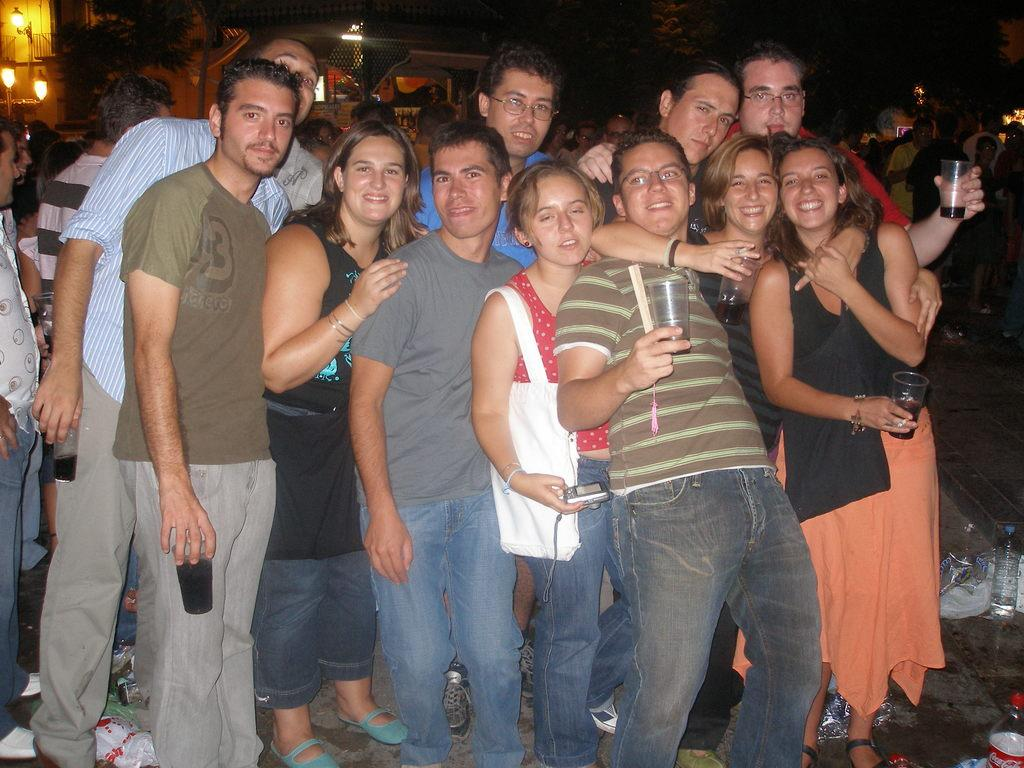What can be seen in the foreground of the image? There is a group of boys and girls in the image. What are the individuals in the group doing? The group is standing in the front of the image and giving a pose to the camera. What is the facial expression of the individuals in the group? The individuals in the group are smiling. What can be seen in the background of the image? There is a house in the background of the image. How would you describe the lighting in the image? The background of the image is dark. What type of agreement was reached by the individuals in the image? There is no indication in the image that the individuals reached any agreement; they are simply posing for a photo. What type of education is being provided to the individuals in the image? There is no indication in the image that the individuals are receiving any education; they are simply posing for a photo. 